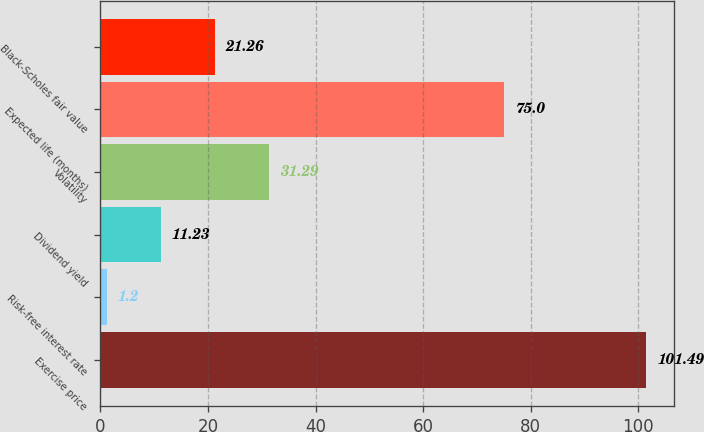Convert chart. <chart><loc_0><loc_0><loc_500><loc_500><bar_chart><fcel>Exercise price<fcel>Risk-free interest rate<fcel>Dividend yield<fcel>Volatility<fcel>Expected life (months)<fcel>Black-Scholes fair value<nl><fcel>101.49<fcel>1.2<fcel>11.23<fcel>31.29<fcel>75<fcel>21.26<nl></chart> 